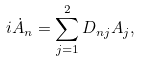<formula> <loc_0><loc_0><loc_500><loc_500>i \dot { A } _ { n } = \sum _ { j = 1 } ^ { 2 } D _ { n j } A _ { j } ,</formula> 